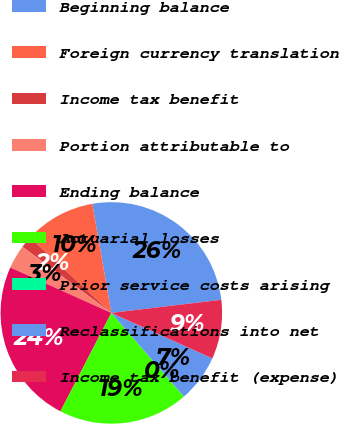<chart> <loc_0><loc_0><loc_500><loc_500><pie_chart><fcel>Beginning balance<fcel>Foreign currency translation<fcel>Income tax benefit<fcel>Portion attributable to<fcel>Ending balance<fcel>Actuarial losses<fcel>Prior service costs arising<fcel>Reclassifications into net<fcel>Income tax benefit (expense)<nl><fcel>25.85%<fcel>10.35%<fcel>1.73%<fcel>3.45%<fcel>24.13%<fcel>18.96%<fcel>0.01%<fcel>6.9%<fcel>8.62%<nl></chart> 